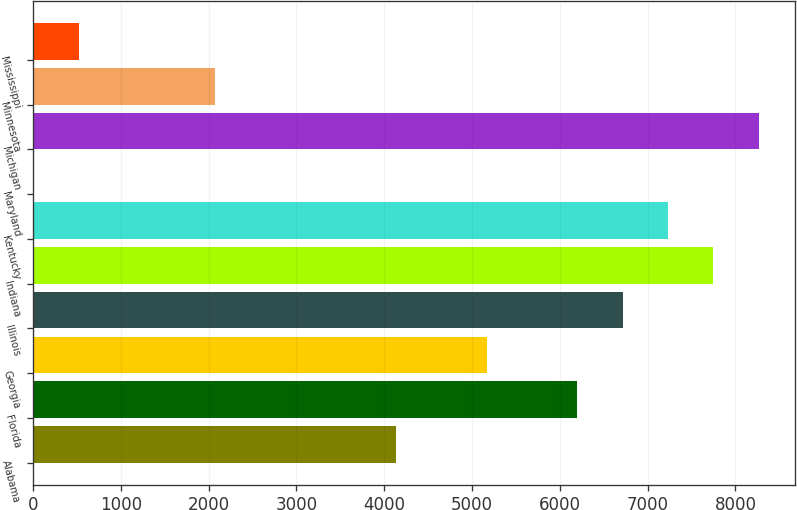Convert chart to OTSL. <chart><loc_0><loc_0><loc_500><loc_500><bar_chart><fcel>Alabama<fcel>Florida<fcel>Georgia<fcel>Illinois<fcel>Indiana<fcel>Kentucky<fcel>Maryland<fcel>Michigan<fcel>Minnesota<fcel>Mississippi<nl><fcel>4133<fcel>6199<fcel>5166<fcel>6715.5<fcel>7748.5<fcel>7232<fcel>1<fcel>8265<fcel>2067<fcel>517.5<nl></chart> 